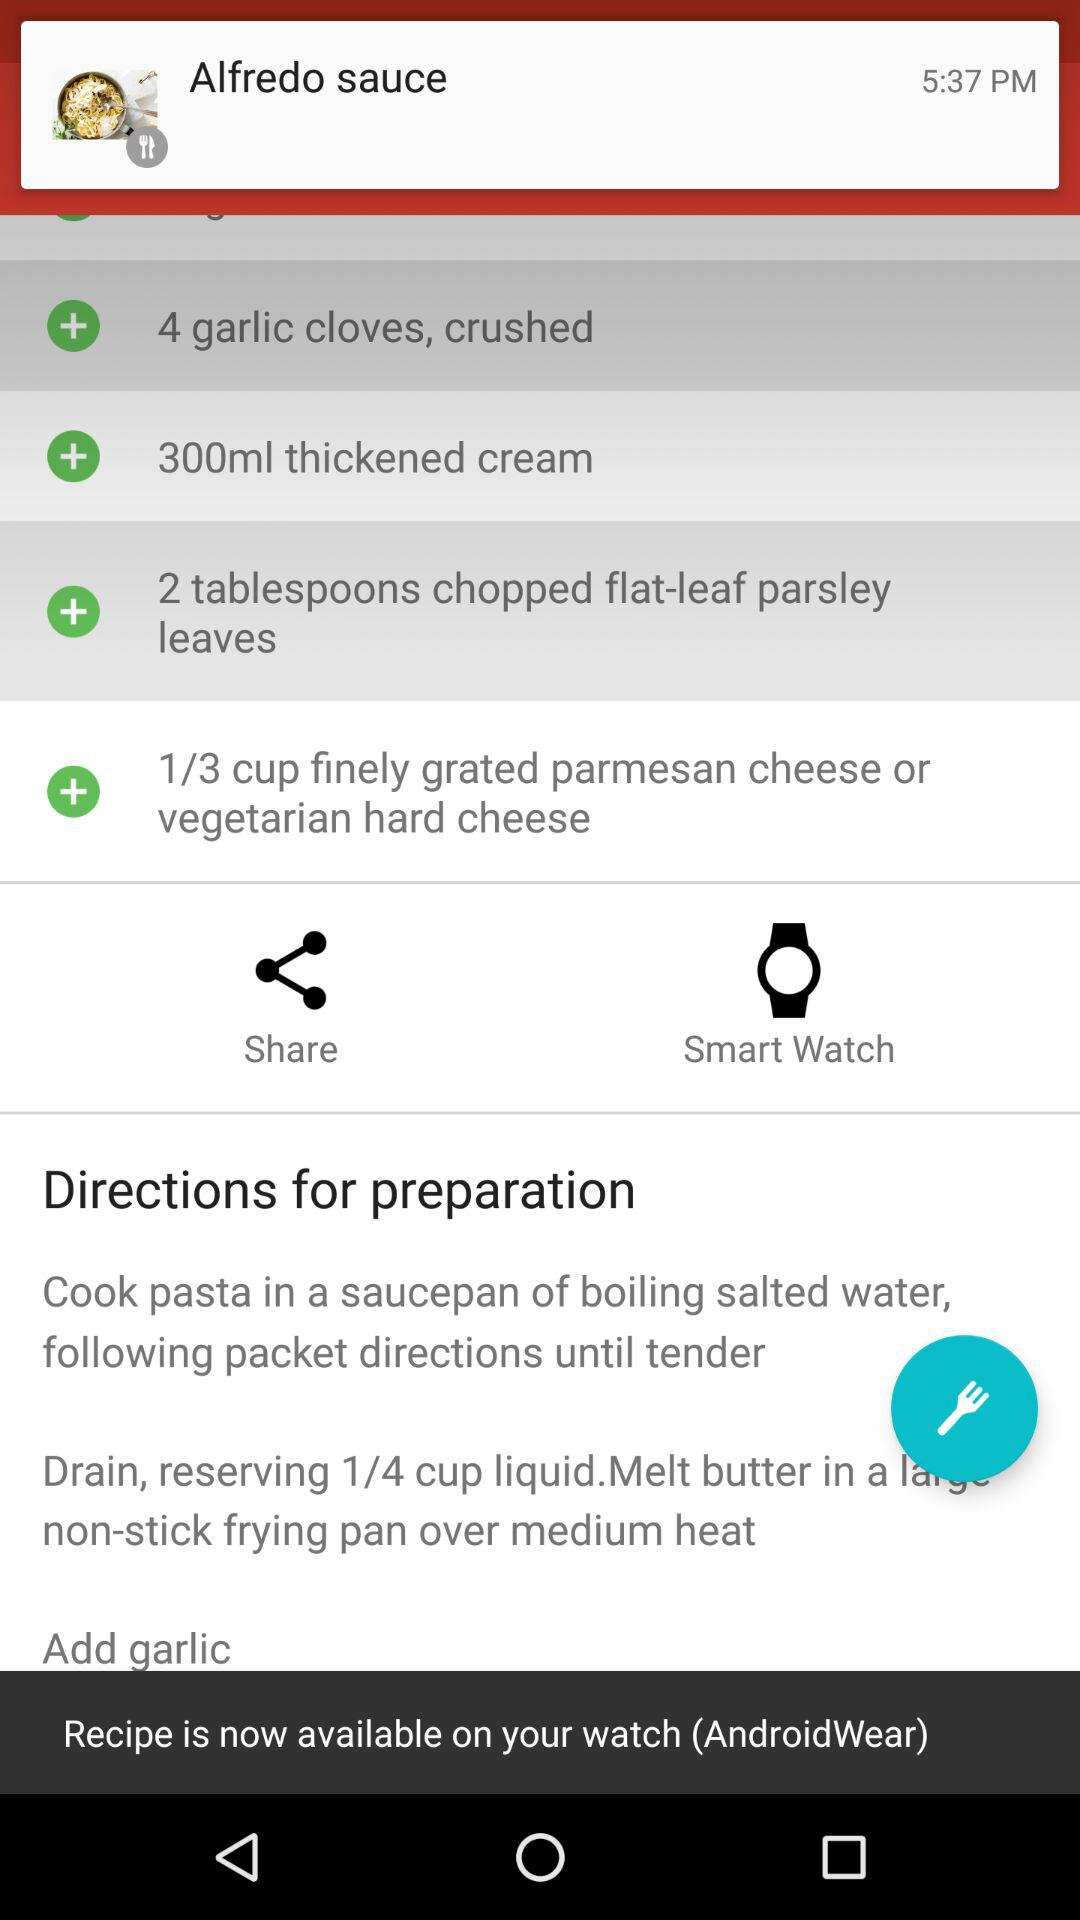How many garlic cloves are required for making pasta? There are 4 garlic cloves required for making pasta. 